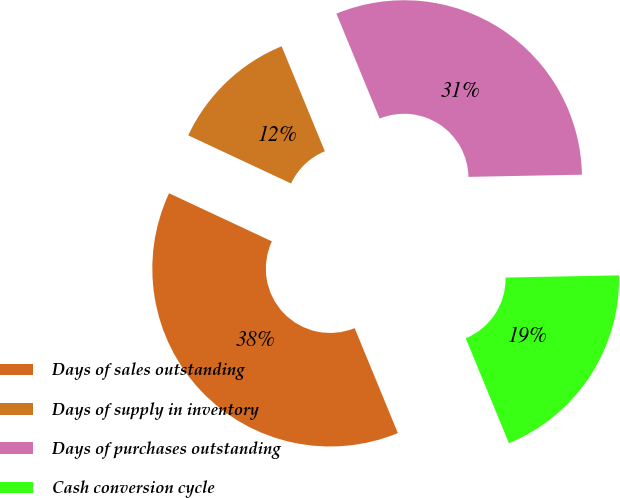Convert chart to OTSL. <chart><loc_0><loc_0><loc_500><loc_500><pie_chart><fcel>Days of sales outstanding<fcel>Days of supply in inventory<fcel>Days of purchases outstanding<fcel>Cash conversion cycle<nl><fcel>38.18%<fcel>11.82%<fcel>30.91%<fcel>19.09%<nl></chart> 